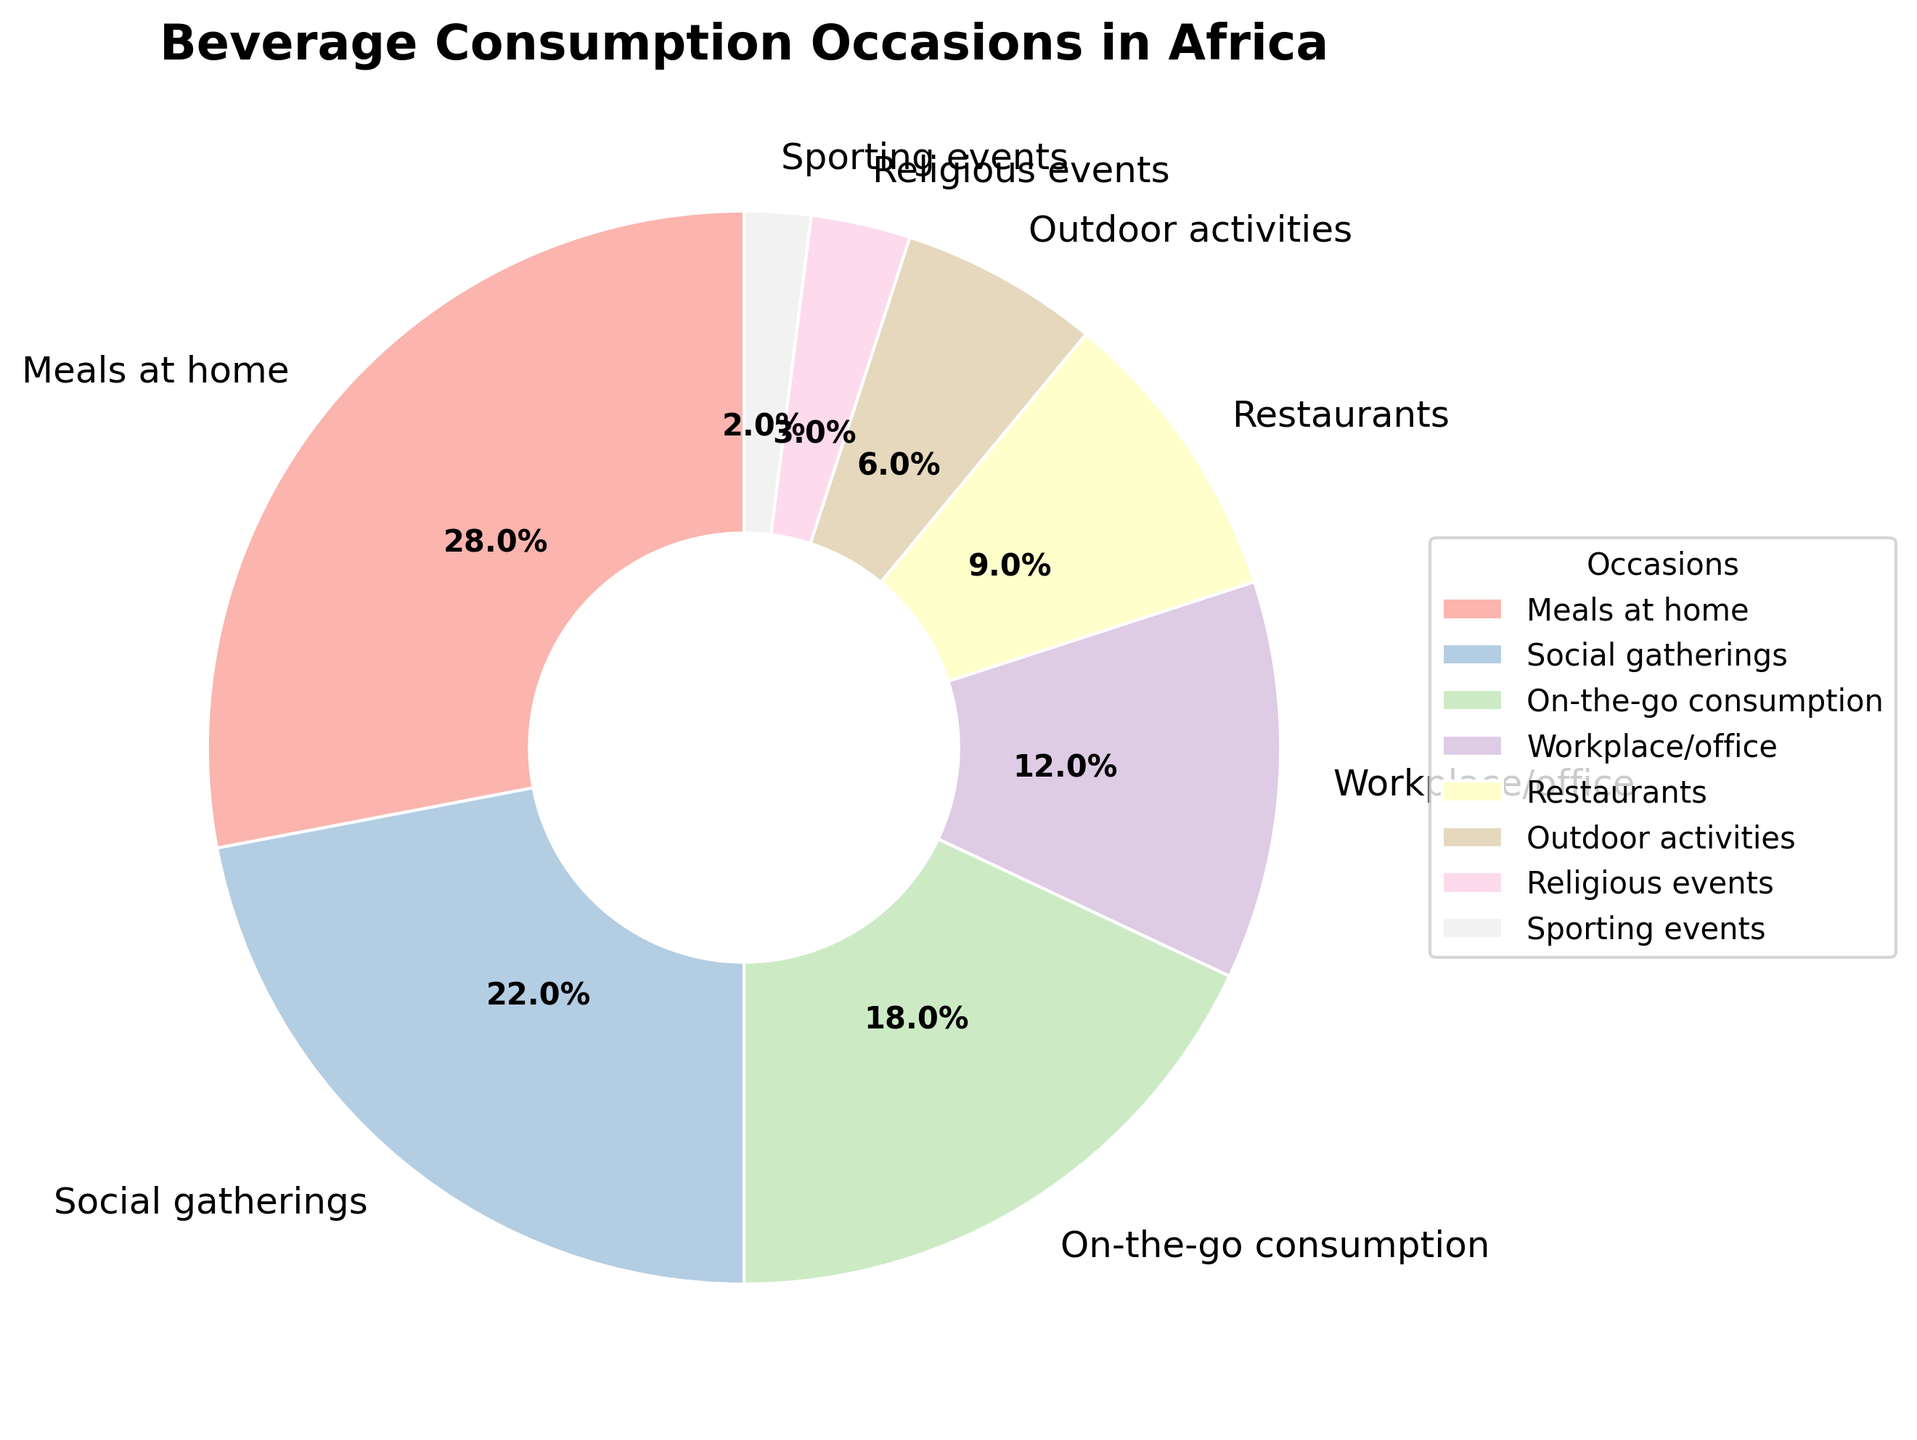Which occasion has the highest percentage of beverage consumption? The occasion with the highest percentage will have the largest slice in the pie chart and will be labeled with the highest percentage. From the data, "Meals at home" has the highest percentage of 28%.
Answer: Meals at home Which two occasions have the smallest combined percentage of beverage consumption? To find the smallest combined percentage, identify the two smallest individual percentages and sum them up. "Sporting events" (2%) and "Religious events" (3%) are the smallest, adding up to 5%.
Answer: Sporting events and Religious events What is the difference in percentage between consumption during meals at home and on-the-go consumption? Find the percentage for "Meals at home" (28%) and "On-the-go consumption" (18%) and subtract the smaller from the larger to get the difference. 28% - 18% = 10%.
Answer: 10% Is consumption at workplace/offices higher or lower than at restaurants? Compare the percentages for "Workplace/office" (12%) and "Restaurants" (9%). Since 12% is greater than 9%, consumption at workplace/offices is higher.
Answer: Higher How much higher is the percentage of social gatherings compared to outdoor activities? Find the percentages for "Social gatherings" (22%) and "Outdoor activities" (6%) and subtract the smaller from the larger to get the difference. 22% - 6% = 16%.
Answer: 16% How do the percentages for social gatherings and on-the-go consumption combined compare to meals at home? First, sum the percentages for "Social gatherings" (22%) and "On-the-go consumption" (18%), which equals 40%. Compare this to "Meals at home" (28%). 40% is greater than 28%.
Answer: Combined percentage is higher Which occasion accounts for roughly one-fifth of the beverage consumption? Identify the occasion where the percentage approximates 20%. "Social gatherings" account for 22%, which is roughly one-fifth of the total.
Answer: Social gatherings What is the total percentage of beverage consumption accounted for by social gatherings, on-the-go consumption, and the workplace/office? Add the percentages for "Social gatherings" (22%), "On-the-go consumption" (18%), and "Workplace/office" (12%) for the total. 22% + 18% + 12% = 52%.
Answer: 52% What is the sum of the percentages for the three occasions with the highest consumption? Identify and sum the three highest percentages: "Meals at home" (28%), "Social gatherings" (22%), and "On-the-go consumption" (18%). 28% + 22% + 18% = 68%.
Answer: 68% Is consumption at religious events more or less than one-third of consumption at social gatherings? Compare the percentage of "Religious events" (3%) with one-third of "Social gatherings" (22%/3 = 7.33%). Since 3% is less than 7.33%, it is less.
Answer: Less 